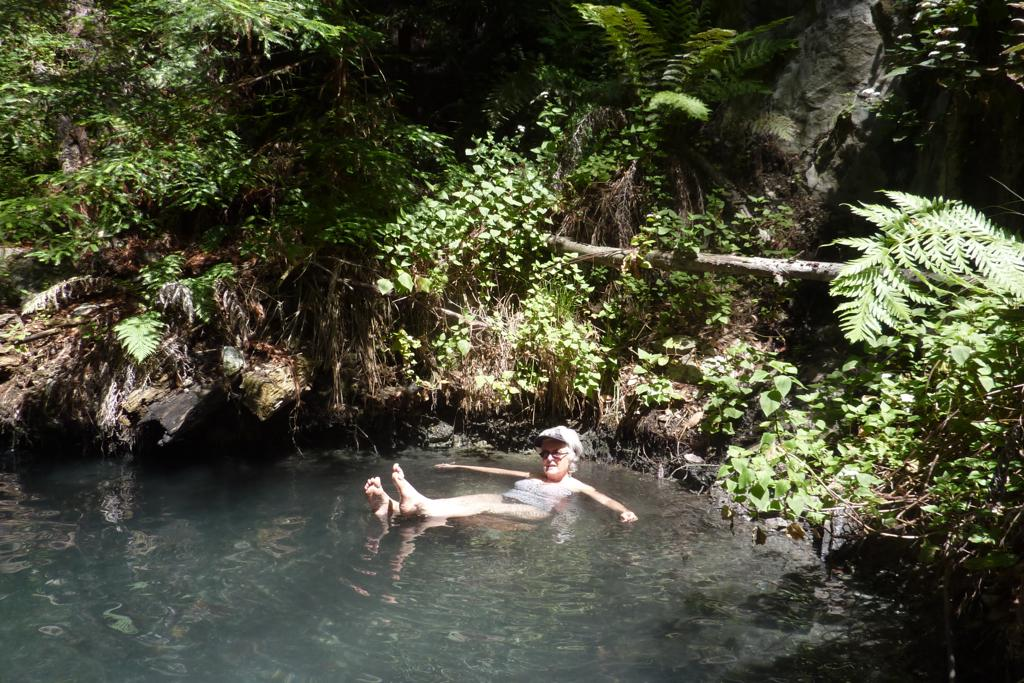What is the primary element in the image? There is water in the image. What is the person in the image doing? There is a person in the water. What type of vegetation can be seen in the image? There are trees in the image. What colors are the trees? The trees are green and brown in color. What other large object is visible in the background of the image? There is a huge rock in the background of the image. What advice does the minister give to the person in the image? There is no minister present in the image, so it is not possible to answer that question. 